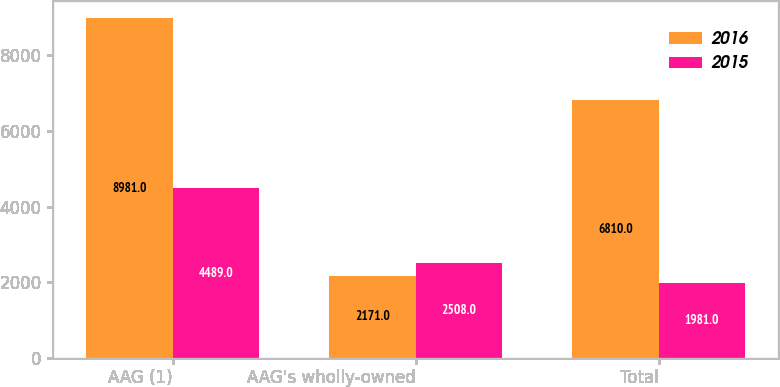Convert chart to OTSL. <chart><loc_0><loc_0><loc_500><loc_500><stacked_bar_chart><ecel><fcel>AAG (1)<fcel>AAG's wholly-owned<fcel>Total<nl><fcel>2016<fcel>8981<fcel>2171<fcel>6810<nl><fcel>2015<fcel>4489<fcel>2508<fcel>1981<nl></chart> 